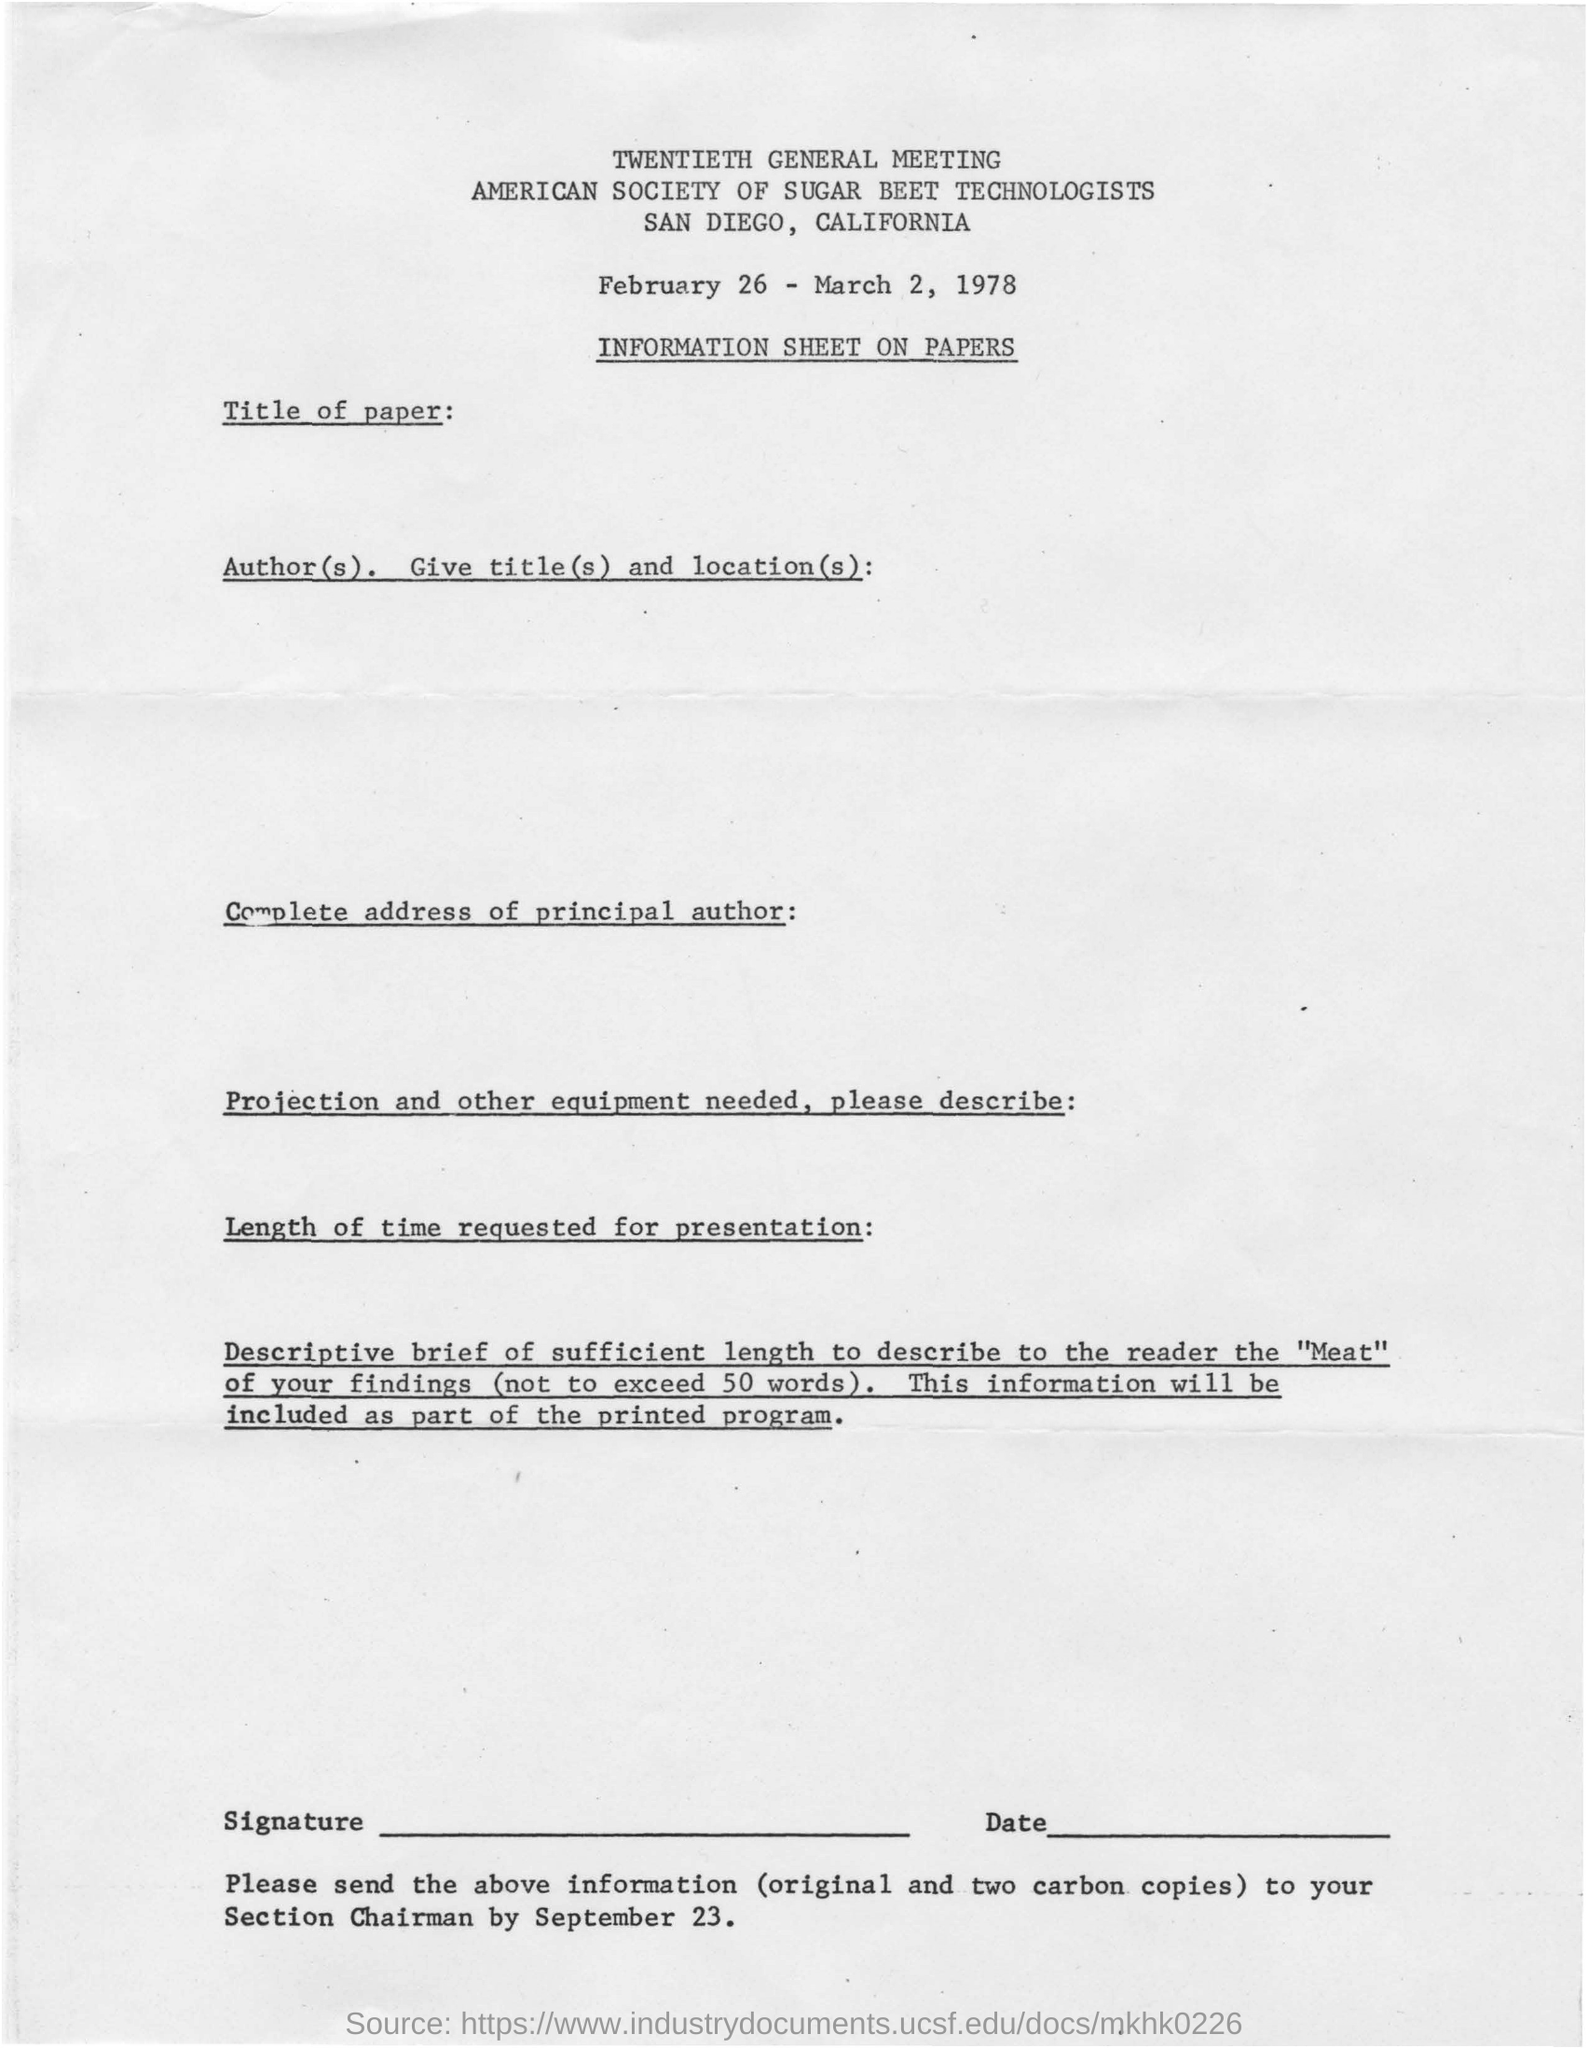What is the address of the american society of sugar beet technologists?
Provide a short and direct response. San Diego, California. What is the date in the document?
Your answer should be very brief. February 26 - March 2, 1978. 